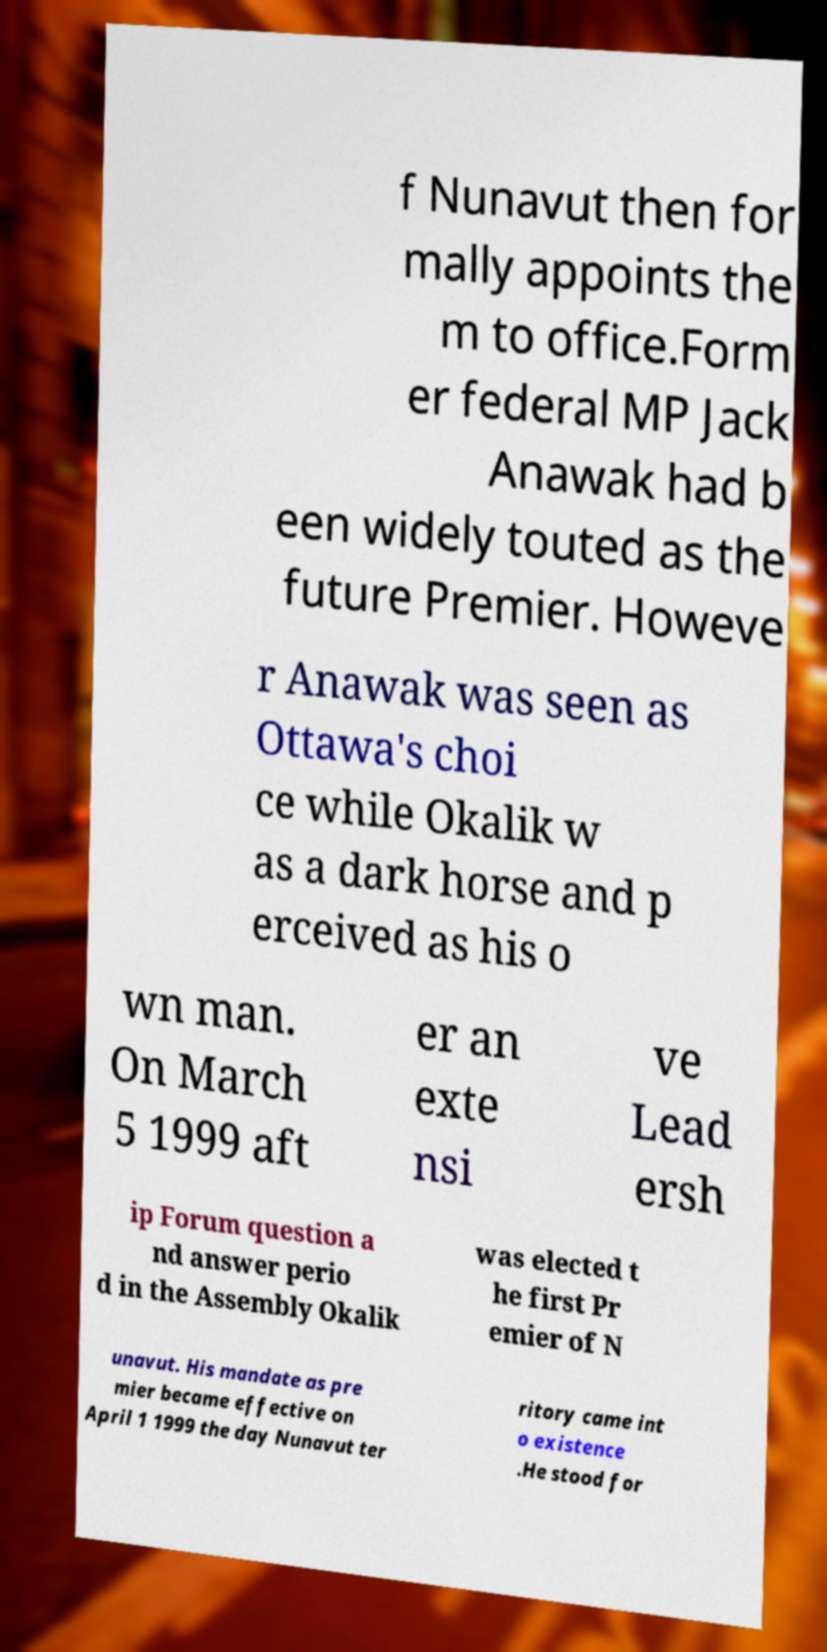What messages or text are displayed in this image? I need them in a readable, typed format. f Nunavut then for mally appoints the m to office.Form er federal MP Jack Anawak had b een widely touted as the future Premier. Howeve r Anawak was seen as Ottawa's choi ce while Okalik w as a dark horse and p erceived as his o wn man. On March 5 1999 aft er an exte nsi ve Lead ersh ip Forum question a nd answer perio d in the Assembly Okalik was elected t he first Pr emier of N unavut. His mandate as pre mier became effective on April 1 1999 the day Nunavut ter ritory came int o existence .He stood for 